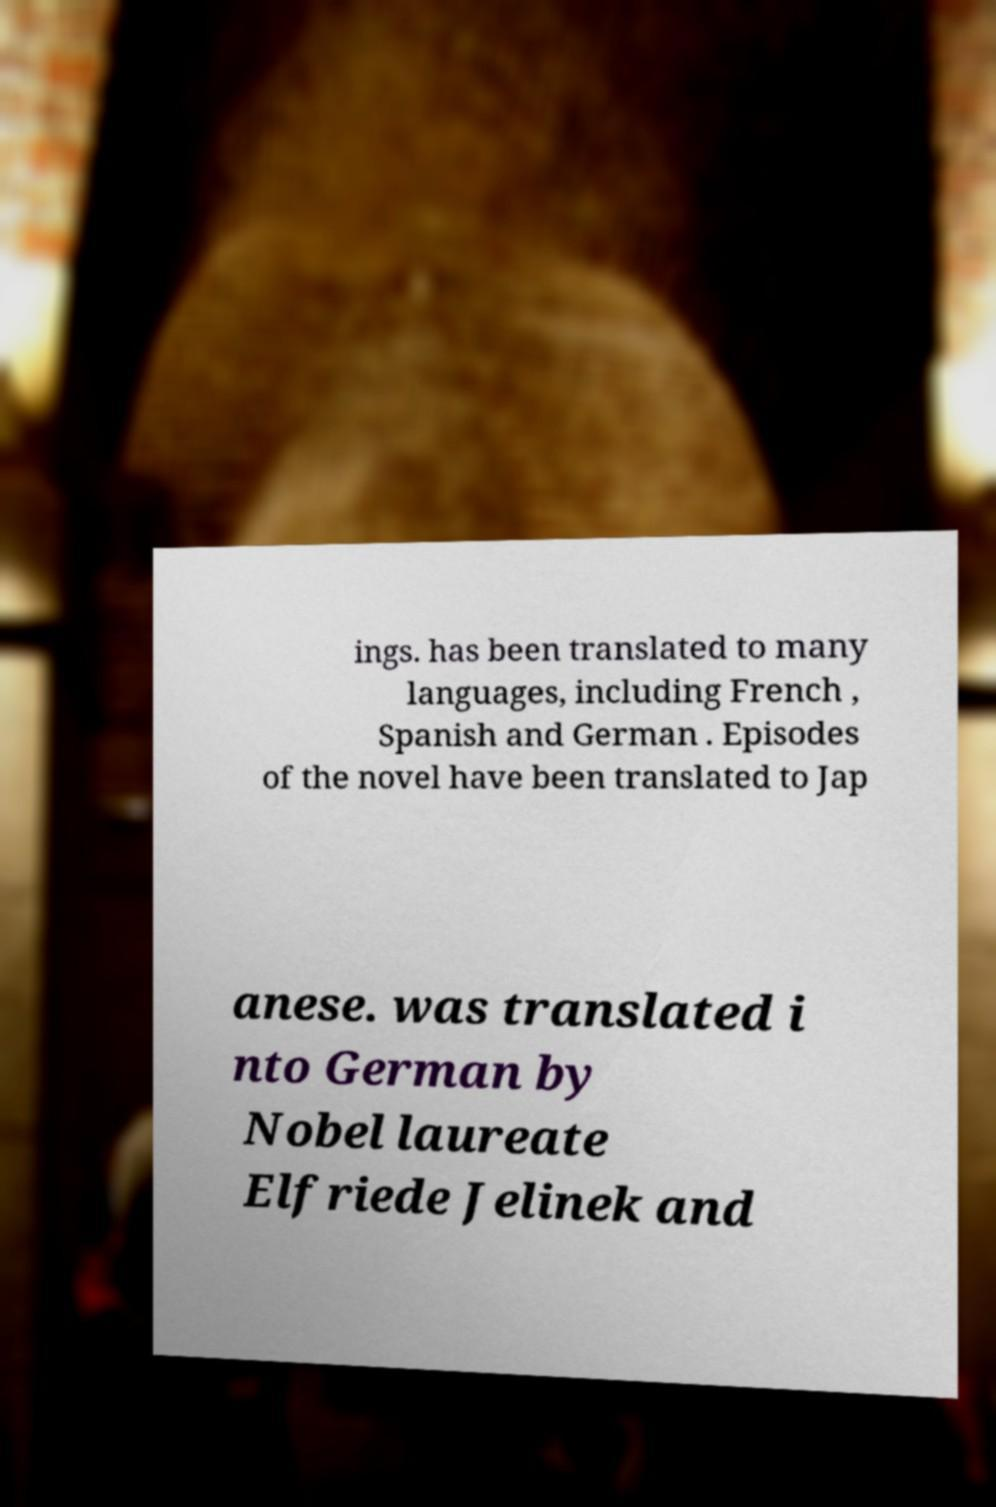Can you read and provide the text displayed in the image?This photo seems to have some interesting text. Can you extract and type it out for me? ings. has been translated to many languages, including French , Spanish and German . Episodes of the novel have been translated to Jap anese. was translated i nto German by Nobel laureate Elfriede Jelinek and 